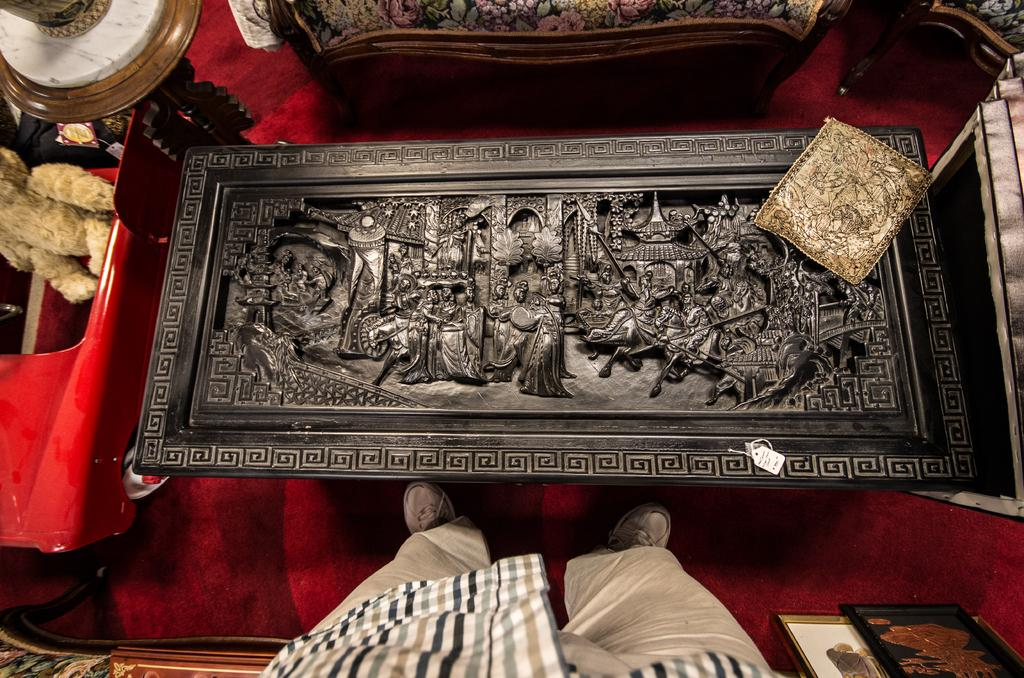What type of furniture is present in the image? There is a table in the image. Can you describe the table in more detail? The table has carvings on it. Who or what is located at the bottom of the image? There is a person standing at the bottom of the image. How many chairs are in the image? There are two chairs in the image. What is on the floor in the image? There is a red carpet on the floor. What type of baseball equipment can be seen on the table in the image? There is no baseball equipment present in the image; the table has carvings on it. How many women are visible in the image? There is no mention of women in the provided facts, and the image does not show any women. 